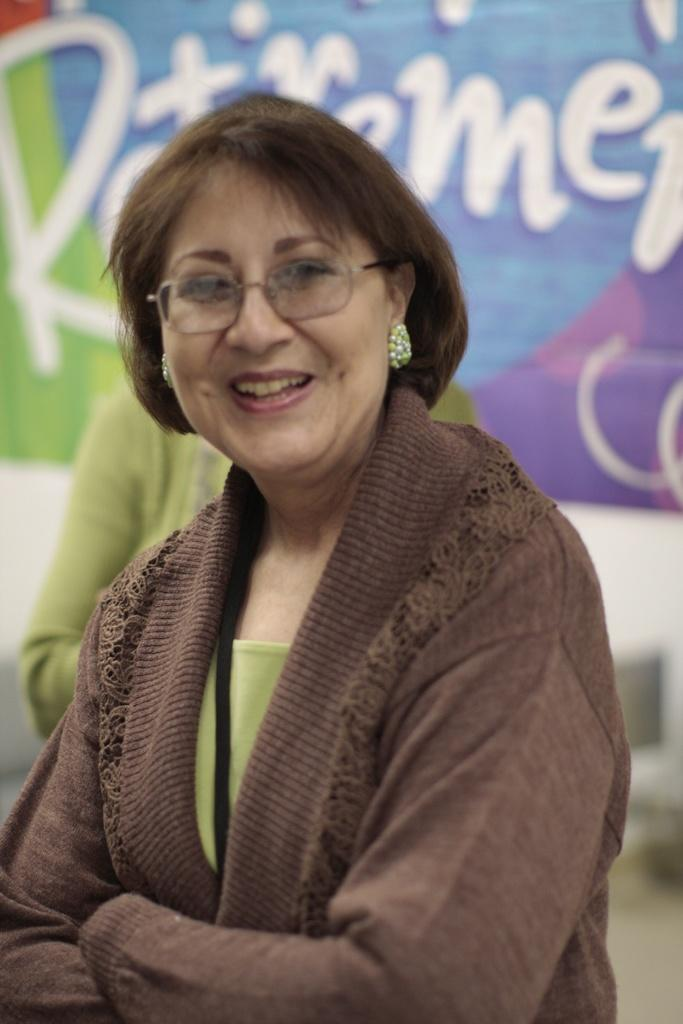Who is present in the image? There is a woman in the image. What is the woman doing in the image? The woman is smiling in the image. What can be seen in the background of the image? There is text visible in the background. Are there any other people in the image? Yes, there is another person in the image. How would you describe the background of the image? The background appears blurry. What type of lamp is    shining on the woman's knee in the image? There is no lamp or knee visible in the image. What holiday is being celebrated in the image? There is no indication of a holiday being celebrated in the image. 